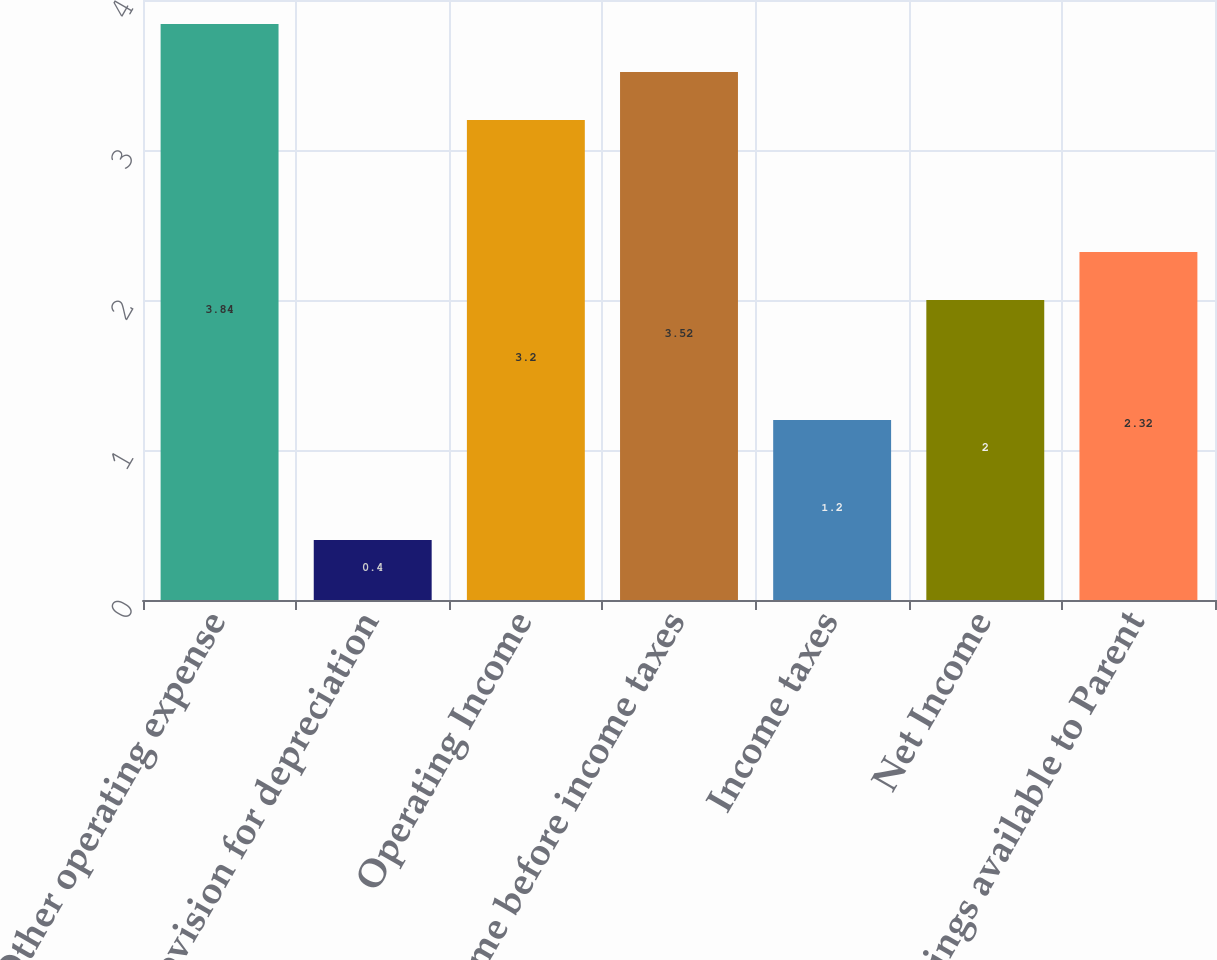Convert chart to OTSL. <chart><loc_0><loc_0><loc_500><loc_500><bar_chart><fcel>Other operating expense<fcel>Provision for depreciation<fcel>Operating Income<fcel>Income before income taxes<fcel>Income taxes<fcel>Net Income<fcel>Earnings available to Parent<nl><fcel>3.84<fcel>0.4<fcel>3.2<fcel>3.52<fcel>1.2<fcel>2<fcel>2.32<nl></chart> 